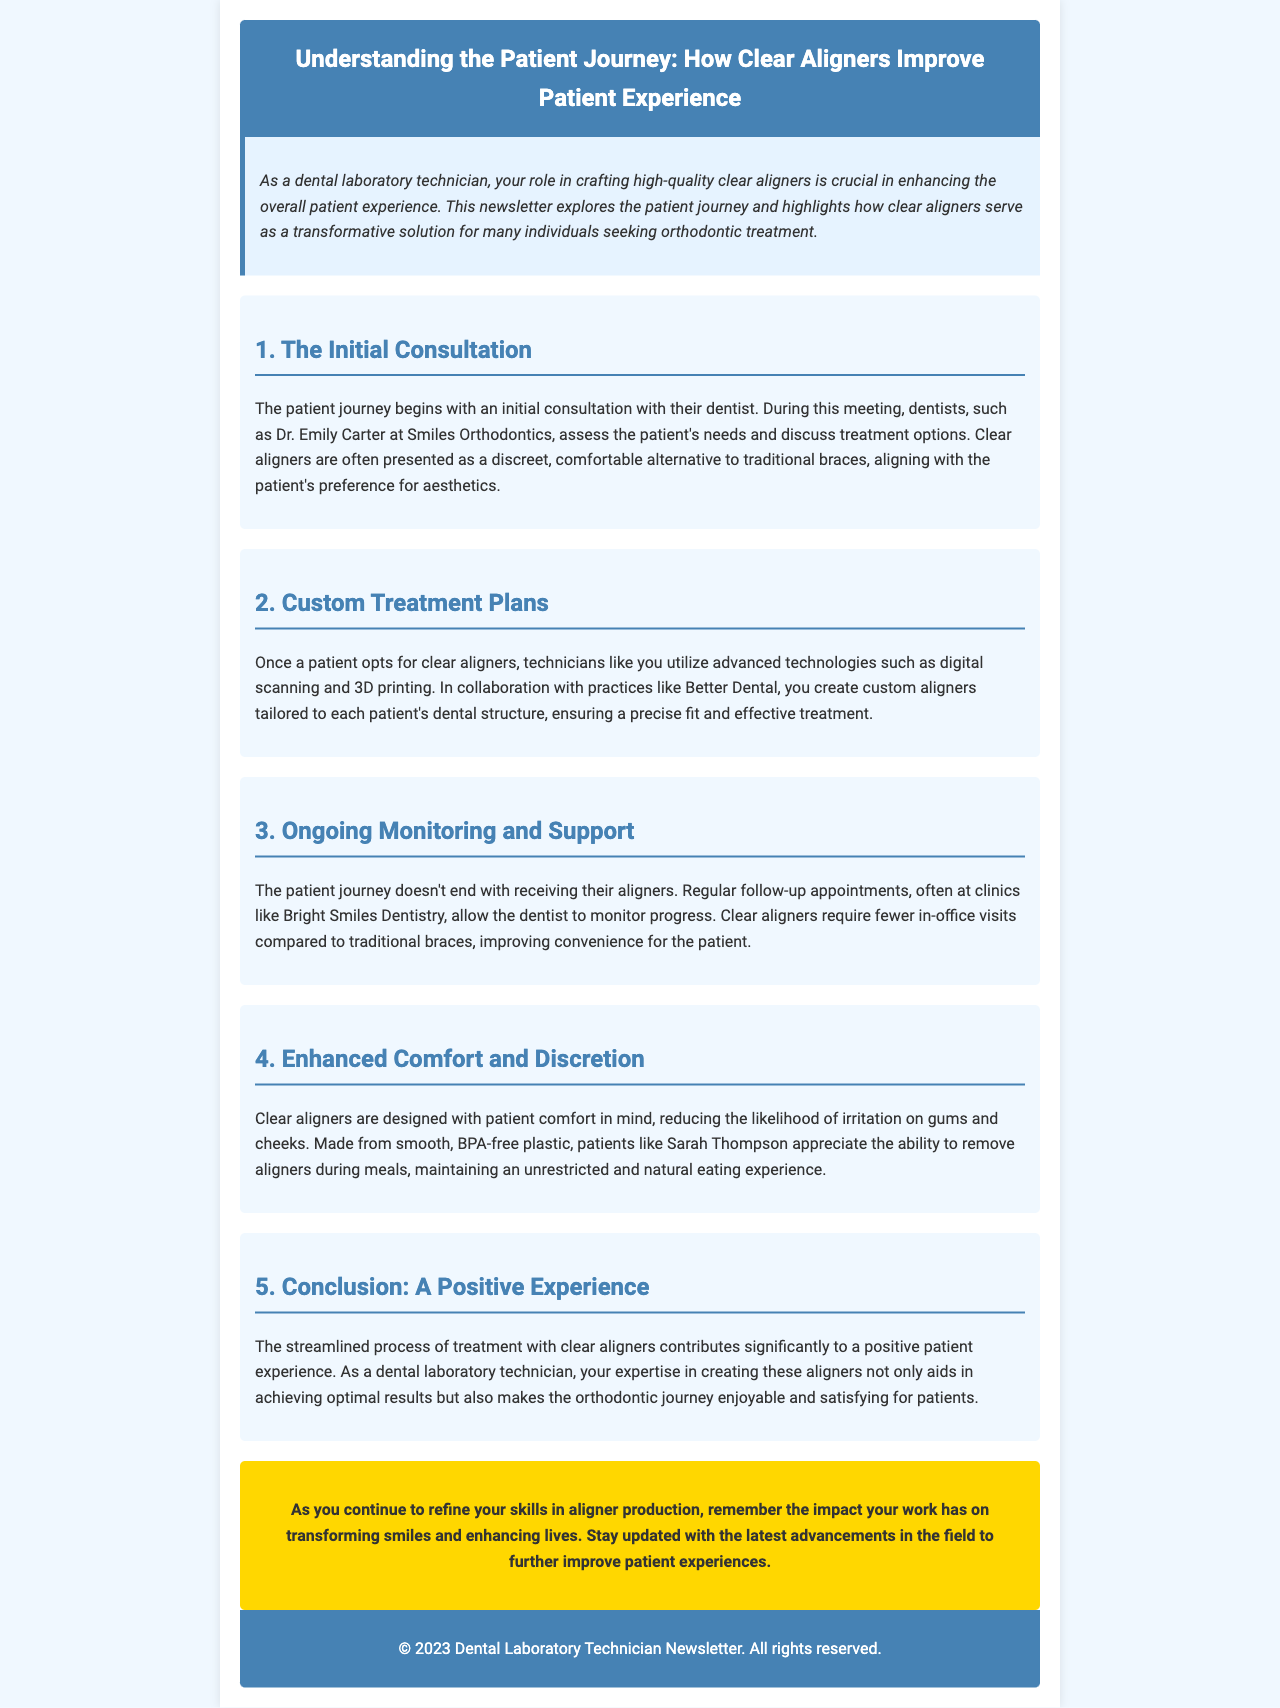What begins the patient journey? The document states that the patient journey begins with an initial consultation with their dentist.
Answer: Initial consultation Who assesses the patient's needs during the consultation? The document mentions Dr. Emily Carter at Smiles Orthodontics as the dentist who assesses the patient's needs.
Answer: Dr. Emily Carter What technology is used to create custom aligners? According to the document, technicians utilize advanced technologies such as digital scanning and 3D printing.
Answer: Digital scanning and 3D printing What is a benefit of clear aligners compared to traditional braces? The document indicates that clear aligners require fewer in-office visits, improving convenience for the patient.
Answer: Fewer in-office visits What material are clear aligners made from? The document states that clear aligners are made from smooth, BPA-free plastic.
Answer: BPA-free plastic What aspect of the patient experience is emphasized in the conclusion? The conclusion highlights that clear aligners contribute significantly to a positive patient experience.
Answer: Positive patient experience Which dental practice allows for ongoing monitoring? The document refers to Bright Smiles Dentistry for regular follow-up appointments.
Answer: Bright Smiles Dentistry What does the CTA encourage technicians to do? The call to action emphasizes the importance of staying updated with the latest advancements in the field.
Answer: Stay updated with the latest advancements 